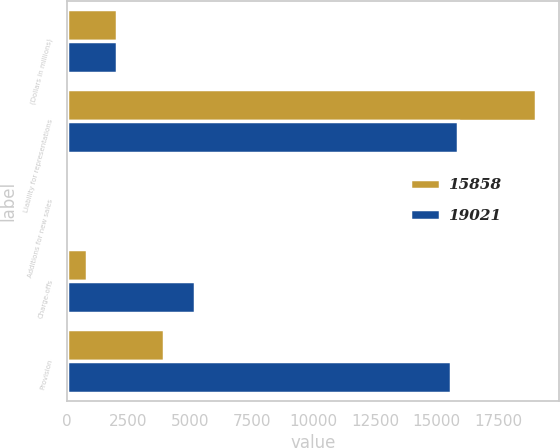Convert chart. <chart><loc_0><loc_0><loc_500><loc_500><stacked_bar_chart><ecel><fcel>(Dollars in millions)<fcel>Liability for representations<fcel>Additions for new sales<fcel>Charge-offs<fcel>Provision<nl><fcel>15858<fcel>2012<fcel>19021<fcel>28<fcel>804<fcel>3939<nl><fcel>19021<fcel>2011<fcel>15858<fcel>20<fcel>5191<fcel>15591<nl></chart> 